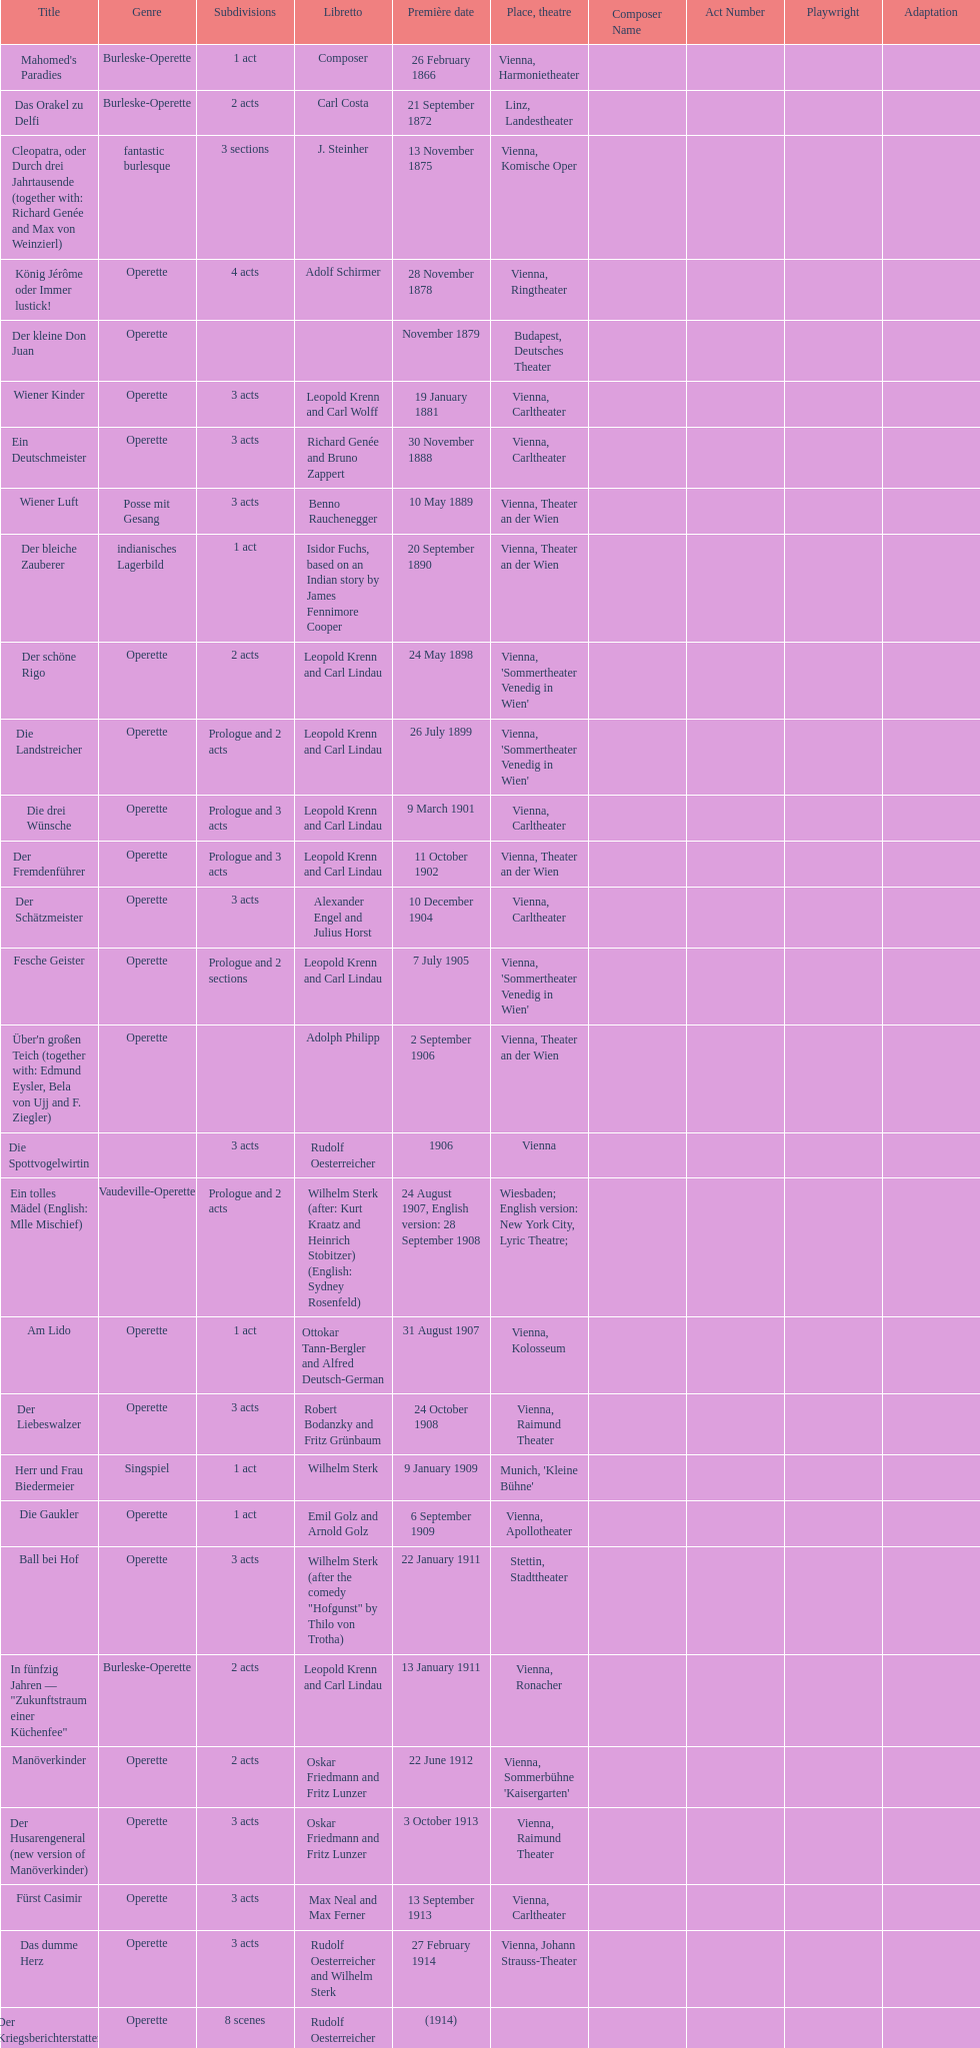How many number of 1 acts were there? 5. 